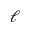Convert formula to latex. <formula><loc_0><loc_0><loc_500><loc_500>\ell</formula> 